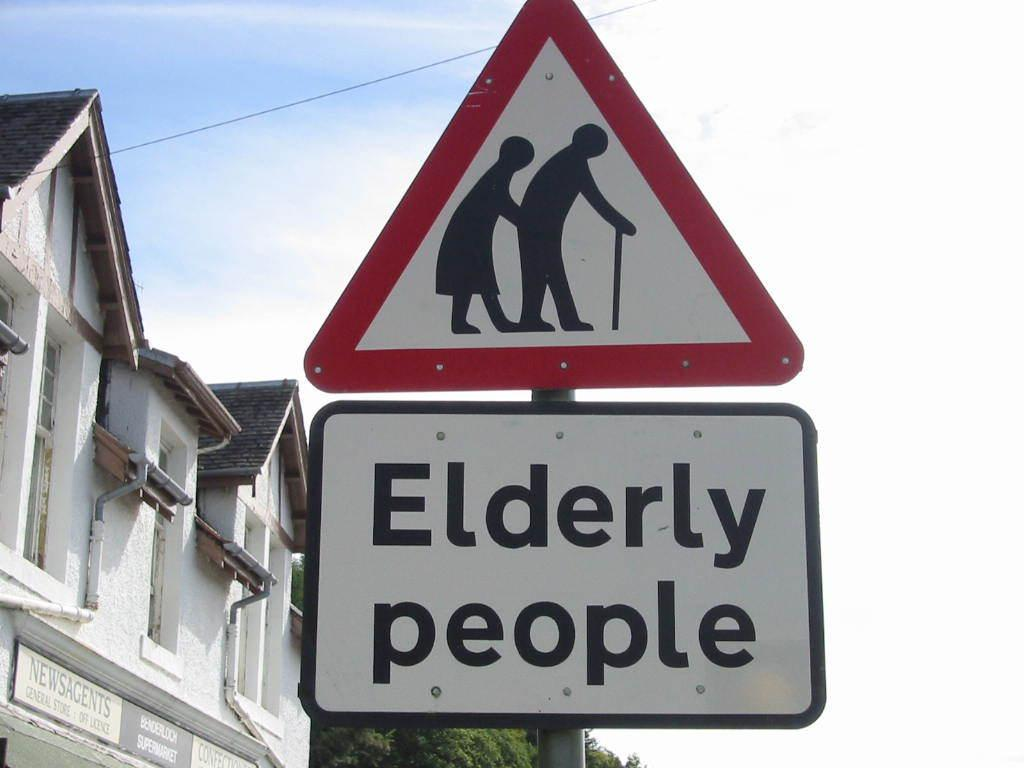Provide a one-sentence caption for the provided image. A sign is posted to show that elderly people are in the area. 